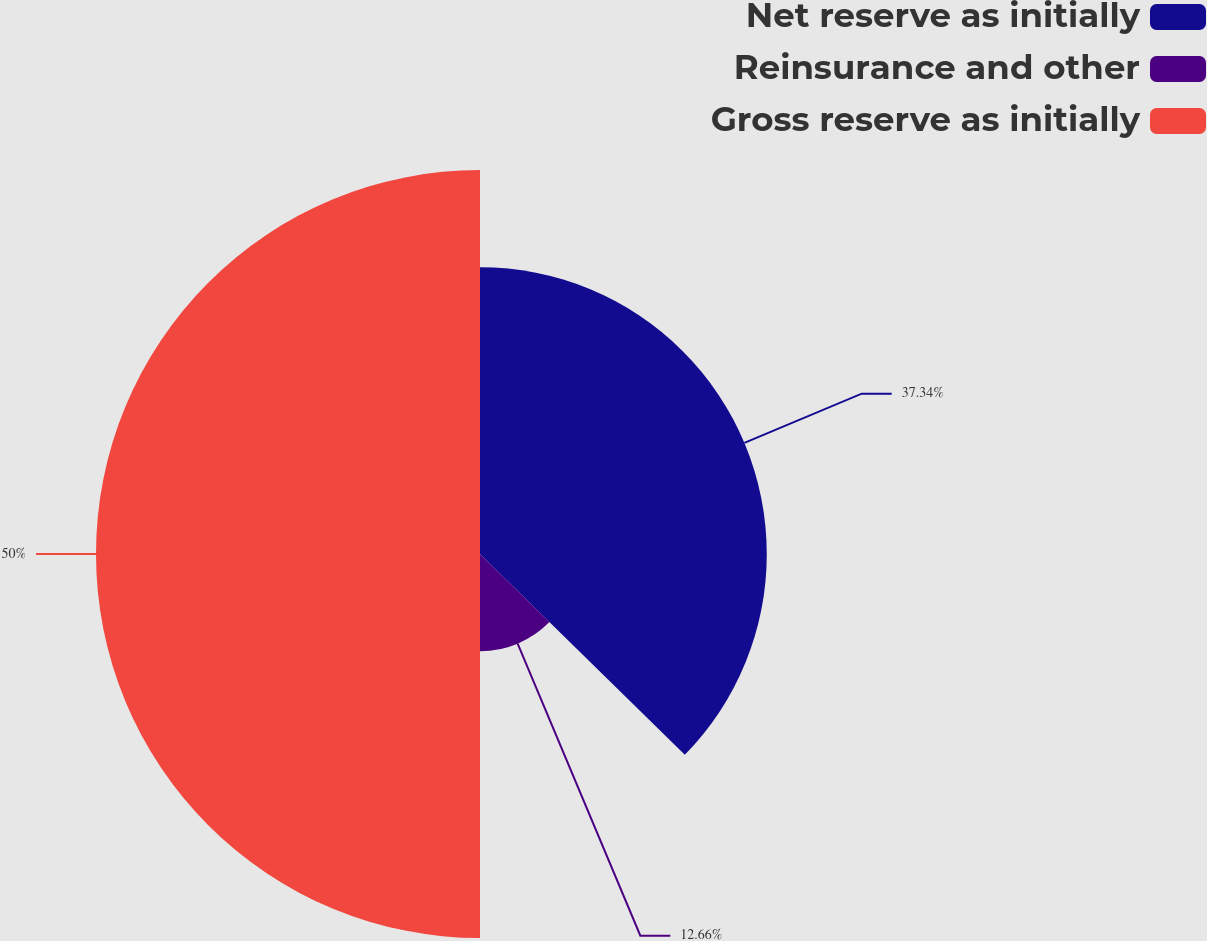<chart> <loc_0><loc_0><loc_500><loc_500><pie_chart><fcel>Net reserve as initially<fcel>Reinsurance and other<fcel>Gross reserve as initially<nl><fcel>37.34%<fcel>12.66%<fcel>50.0%<nl></chart> 